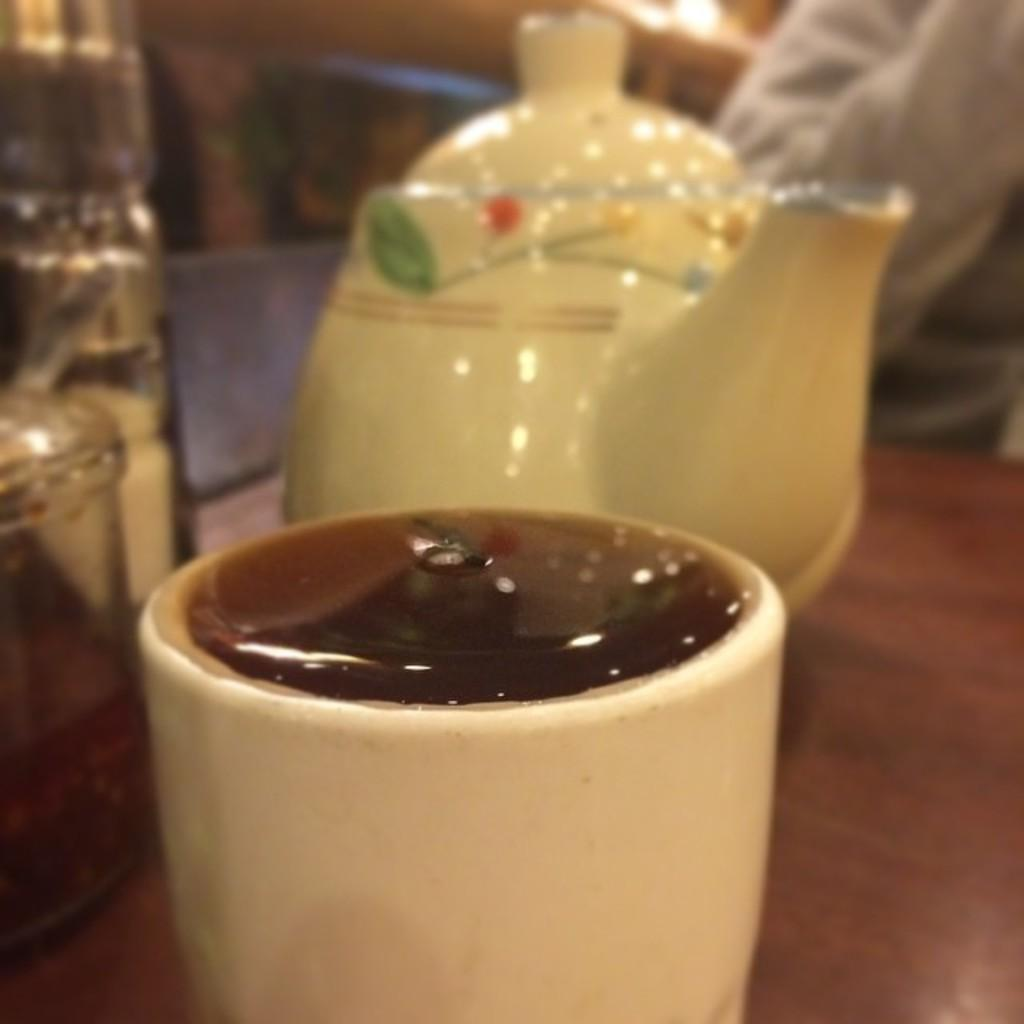What is the main object on the table in the image? There is a kettle in the image. What else can be seen on the table? There is a cup and other objects on the table. Can you describe the person in the image? There is a person on the right side behind the table. What type of quilt is being used to cover the table in the image? There is no quilt present in the image; it only shows a kettle, a cup, and other objects on the table. 